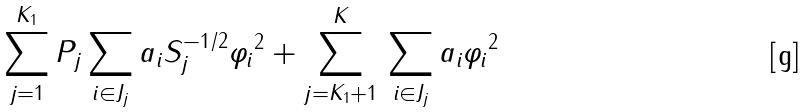Convert formula to latex. <formula><loc_0><loc_0><loc_500><loc_500>\sum _ { j = 1 } ^ { K _ { 1 } } \| P _ { j } \sum _ { i \in J _ { j } } a _ { i } S _ { j } ^ { - 1 / 2 } \varphi _ { i } \| ^ { 2 } + \sum _ { j = K _ { 1 } + 1 } ^ { K } \| \sum _ { i \in J _ { j } } a _ { i } \varphi _ { i } \| ^ { 2 }</formula> 